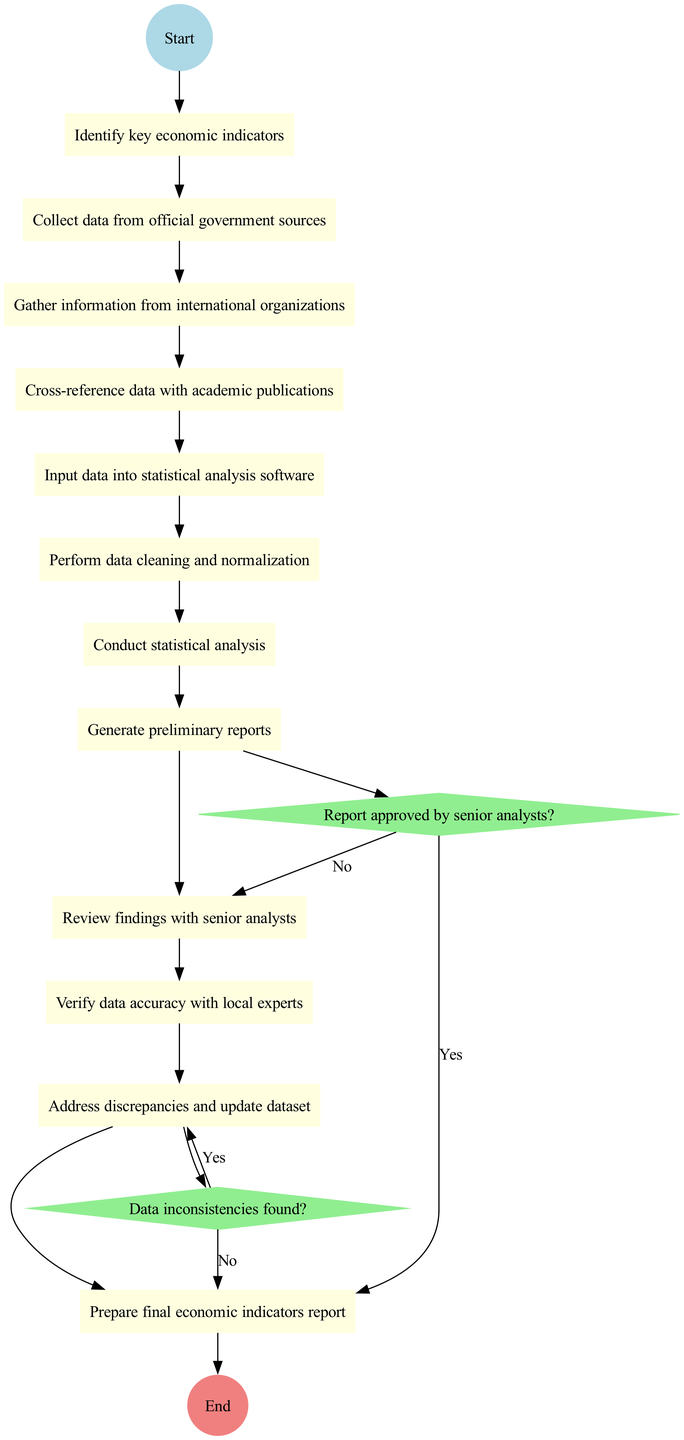What is the starting point of the activity diagram? The diagram begins with the node labeled "Start," which indicates the initiation of the data compilation process.
Answer: Start How many activities are listed in the diagram? The diagram contains a total of 12 activities, as outlined in the activities section of the data.
Answer: 12 What is the last activity before the end? The last activity prior to reaching the end of the process is "Prepare final economic indicators report," as seen just before the end node.
Answer: Prepare final economic indicators report What happens if data inconsistencies are found? If data inconsistencies are detected, the flow directs to the activity "Address discrepancies and update dataset," indicating a need to rectify the inconsistencies before proceeding.
Answer: Address discrepancies and update dataset What decision must be made after generating preliminary reports? After generating preliminary reports, a decision must be made regarding whether the report is approved by senior analysts. This leads to either preparing the final report or reviewing findings further.
Answer: Report approved by senior analysts? What is the relationship between "Cross-reference data with academic publications" and "Perform data cleaning and normalization"? The activities are sequential; after "Cross-reference data with academic publications," the next step is "Perform data cleaning and normalization," which indicates that data refinement follows the cross-referencing.
Answer: Sequential relationship If the report is not approved by senior analysts, what is the next step? If the report is not approved, the process loops back to "Review findings with senior analysts," indicating a further review is necessary before finalizing the report.
Answer: Review findings with senior analysts How many decision nodes are present in the diagram? There are 2 decision nodes in the diagram, representing points where choices must be made regarding data and report approval.
Answer: 2 What is indicated by the "End" node of the diagram? The "End" node signifies the completion of the process, specifically after submitting the final report for policy analysis.
Answer: Submit report for policy analysis 